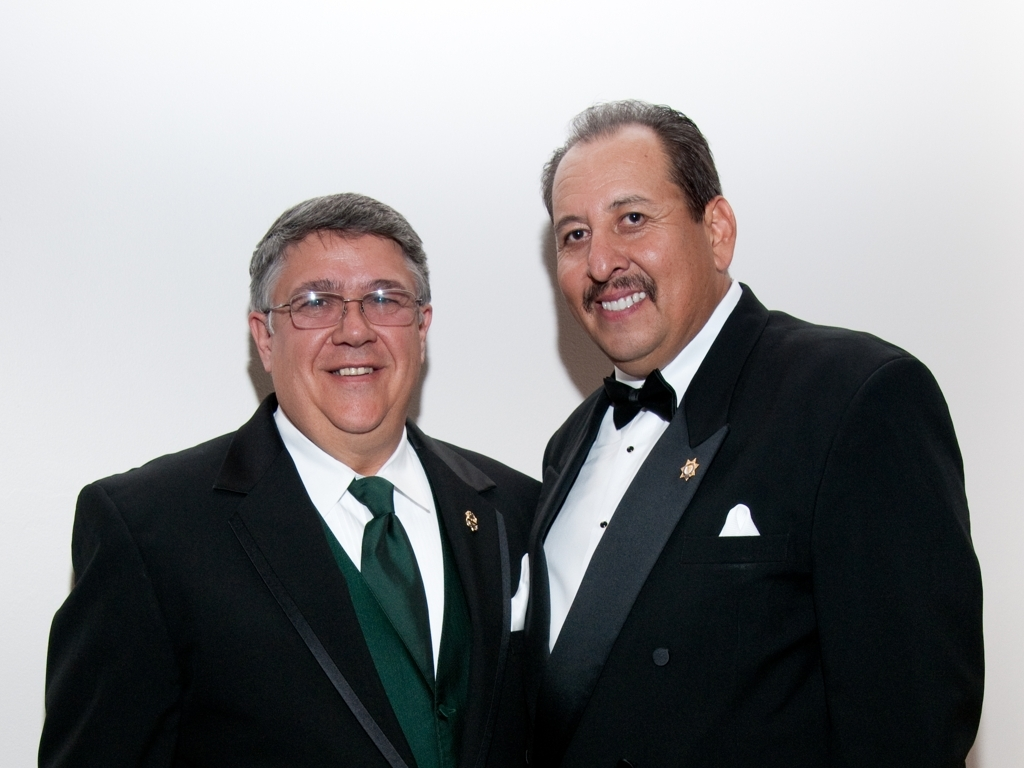How clear is the facial features in the image?
 Clear 